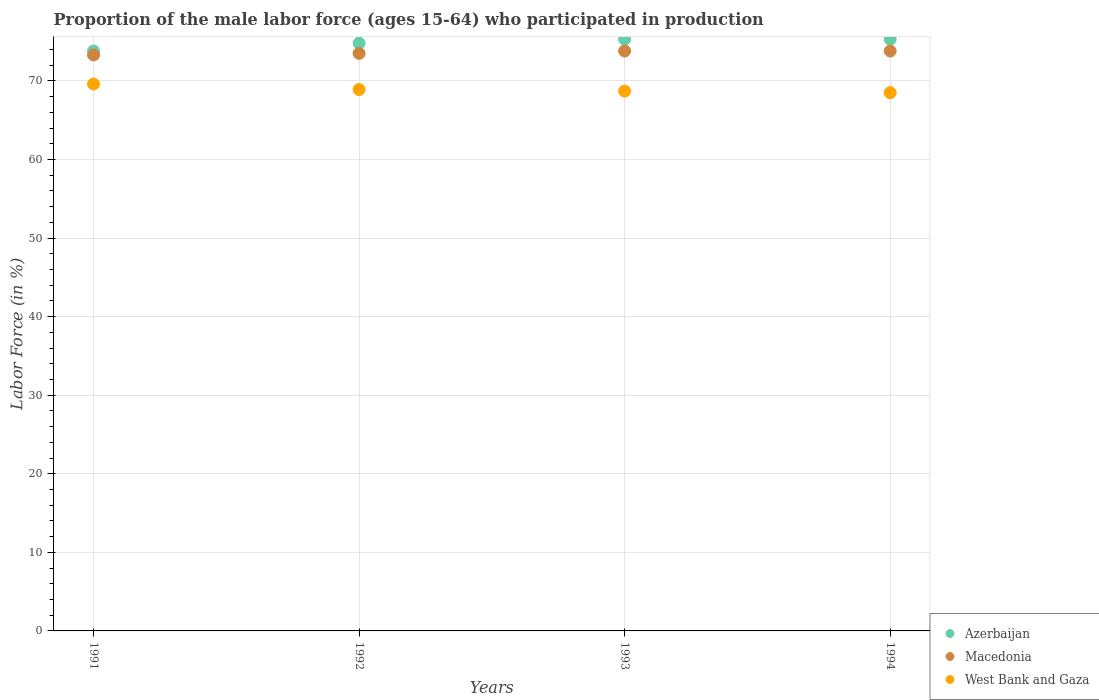Is the number of dotlines equal to the number of legend labels?
Offer a very short reply. Yes. What is the proportion of the male labor force who participated in production in West Bank and Gaza in 1993?
Provide a succinct answer. 68.7. Across all years, what is the maximum proportion of the male labor force who participated in production in Azerbaijan?
Provide a succinct answer. 75.3. Across all years, what is the minimum proportion of the male labor force who participated in production in West Bank and Gaza?
Give a very brief answer. 68.5. In which year was the proportion of the male labor force who participated in production in West Bank and Gaza maximum?
Keep it short and to the point. 1991. What is the total proportion of the male labor force who participated in production in Macedonia in the graph?
Give a very brief answer. 294.4. What is the difference between the proportion of the male labor force who participated in production in Azerbaijan in 1993 and the proportion of the male labor force who participated in production in Macedonia in 1994?
Give a very brief answer. 1.5. What is the average proportion of the male labor force who participated in production in West Bank and Gaza per year?
Make the answer very short. 68.92. In the year 1993, what is the difference between the proportion of the male labor force who participated in production in Macedonia and proportion of the male labor force who participated in production in West Bank and Gaza?
Ensure brevity in your answer.  5.1. In how many years, is the proportion of the male labor force who participated in production in Macedonia greater than 50 %?
Provide a short and direct response. 4. What is the ratio of the proportion of the male labor force who participated in production in Azerbaijan in 1991 to that in 1993?
Ensure brevity in your answer.  0.98. Is the proportion of the male labor force who participated in production in Macedonia in 1992 less than that in 1993?
Make the answer very short. Yes. What is the difference between the highest and the second highest proportion of the male labor force who participated in production in West Bank and Gaza?
Your response must be concise. 0.7. What is the difference between the highest and the lowest proportion of the male labor force who participated in production in West Bank and Gaza?
Make the answer very short. 1.1. In how many years, is the proportion of the male labor force who participated in production in Macedonia greater than the average proportion of the male labor force who participated in production in Macedonia taken over all years?
Give a very brief answer. 2. Is it the case that in every year, the sum of the proportion of the male labor force who participated in production in Macedonia and proportion of the male labor force who participated in production in Azerbaijan  is greater than the proportion of the male labor force who participated in production in West Bank and Gaza?
Ensure brevity in your answer.  Yes. Is the proportion of the male labor force who participated in production in West Bank and Gaza strictly greater than the proportion of the male labor force who participated in production in Azerbaijan over the years?
Provide a succinct answer. No. How many dotlines are there?
Provide a short and direct response. 3. How many years are there in the graph?
Make the answer very short. 4. What is the difference between two consecutive major ticks on the Y-axis?
Make the answer very short. 10. Where does the legend appear in the graph?
Offer a very short reply. Bottom right. What is the title of the graph?
Keep it short and to the point. Proportion of the male labor force (ages 15-64) who participated in production. What is the label or title of the Y-axis?
Make the answer very short. Labor Force (in %). What is the Labor Force (in %) of Azerbaijan in 1991?
Your answer should be very brief. 73.8. What is the Labor Force (in %) in Macedonia in 1991?
Make the answer very short. 73.3. What is the Labor Force (in %) in West Bank and Gaza in 1991?
Keep it short and to the point. 69.6. What is the Labor Force (in %) in Azerbaijan in 1992?
Your answer should be compact. 74.8. What is the Labor Force (in %) of Macedonia in 1992?
Your response must be concise. 73.5. What is the Labor Force (in %) in West Bank and Gaza in 1992?
Your answer should be compact. 68.9. What is the Labor Force (in %) in Azerbaijan in 1993?
Ensure brevity in your answer.  75.3. What is the Labor Force (in %) of Macedonia in 1993?
Ensure brevity in your answer.  73.8. What is the Labor Force (in %) of West Bank and Gaza in 1993?
Keep it short and to the point. 68.7. What is the Labor Force (in %) of Azerbaijan in 1994?
Make the answer very short. 75.3. What is the Labor Force (in %) of Macedonia in 1994?
Give a very brief answer. 73.8. What is the Labor Force (in %) in West Bank and Gaza in 1994?
Provide a short and direct response. 68.5. Across all years, what is the maximum Labor Force (in %) in Azerbaijan?
Offer a terse response. 75.3. Across all years, what is the maximum Labor Force (in %) of Macedonia?
Keep it short and to the point. 73.8. Across all years, what is the maximum Labor Force (in %) of West Bank and Gaza?
Provide a short and direct response. 69.6. Across all years, what is the minimum Labor Force (in %) in Azerbaijan?
Offer a very short reply. 73.8. Across all years, what is the minimum Labor Force (in %) of Macedonia?
Ensure brevity in your answer.  73.3. Across all years, what is the minimum Labor Force (in %) of West Bank and Gaza?
Keep it short and to the point. 68.5. What is the total Labor Force (in %) in Azerbaijan in the graph?
Your response must be concise. 299.2. What is the total Labor Force (in %) of Macedonia in the graph?
Offer a terse response. 294.4. What is the total Labor Force (in %) in West Bank and Gaza in the graph?
Ensure brevity in your answer.  275.7. What is the difference between the Labor Force (in %) in Macedonia in 1991 and that in 1992?
Offer a very short reply. -0.2. What is the difference between the Labor Force (in %) of West Bank and Gaza in 1991 and that in 1992?
Your response must be concise. 0.7. What is the difference between the Labor Force (in %) in Azerbaijan in 1991 and that in 1993?
Ensure brevity in your answer.  -1.5. What is the difference between the Labor Force (in %) in Azerbaijan in 1991 and that in 1994?
Your answer should be compact. -1.5. What is the difference between the Labor Force (in %) of Macedonia in 1991 and that in 1994?
Your answer should be very brief. -0.5. What is the difference between the Labor Force (in %) in Azerbaijan in 1992 and that in 1993?
Make the answer very short. -0.5. What is the difference between the Labor Force (in %) in Macedonia in 1992 and that in 1993?
Your answer should be compact. -0.3. What is the difference between the Labor Force (in %) of West Bank and Gaza in 1992 and that in 1993?
Offer a very short reply. 0.2. What is the difference between the Labor Force (in %) in West Bank and Gaza in 1992 and that in 1994?
Your answer should be very brief. 0.4. What is the difference between the Labor Force (in %) in Macedonia in 1993 and that in 1994?
Provide a short and direct response. 0. What is the difference between the Labor Force (in %) of West Bank and Gaza in 1993 and that in 1994?
Make the answer very short. 0.2. What is the difference between the Labor Force (in %) in Azerbaijan in 1991 and the Labor Force (in %) in West Bank and Gaza in 1992?
Offer a very short reply. 4.9. What is the difference between the Labor Force (in %) of Azerbaijan in 1991 and the Labor Force (in %) of Macedonia in 1993?
Your answer should be very brief. 0. What is the difference between the Labor Force (in %) of Azerbaijan in 1991 and the Labor Force (in %) of West Bank and Gaza in 1993?
Offer a terse response. 5.1. What is the difference between the Labor Force (in %) in Macedonia in 1991 and the Labor Force (in %) in West Bank and Gaza in 1993?
Offer a terse response. 4.6. What is the difference between the Labor Force (in %) of Azerbaijan in 1991 and the Labor Force (in %) of West Bank and Gaza in 1994?
Keep it short and to the point. 5.3. What is the difference between the Labor Force (in %) of Azerbaijan in 1992 and the Labor Force (in %) of Macedonia in 1993?
Your response must be concise. 1. What is the difference between the Labor Force (in %) in Macedonia in 1992 and the Labor Force (in %) in West Bank and Gaza in 1993?
Your response must be concise. 4.8. What is the difference between the Labor Force (in %) in Azerbaijan in 1992 and the Labor Force (in %) in West Bank and Gaza in 1994?
Make the answer very short. 6.3. What is the difference between the Labor Force (in %) of Macedonia in 1992 and the Labor Force (in %) of West Bank and Gaza in 1994?
Your response must be concise. 5. What is the difference between the Labor Force (in %) in Azerbaijan in 1993 and the Labor Force (in %) in Macedonia in 1994?
Provide a succinct answer. 1.5. What is the difference between the Labor Force (in %) in Azerbaijan in 1993 and the Labor Force (in %) in West Bank and Gaza in 1994?
Provide a succinct answer. 6.8. What is the average Labor Force (in %) of Azerbaijan per year?
Offer a terse response. 74.8. What is the average Labor Force (in %) of Macedonia per year?
Provide a short and direct response. 73.6. What is the average Labor Force (in %) of West Bank and Gaza per year?
Make the answer very short. 68.92. In the year 1991, what is the difference between the Labor Force (in %) in Azerbaijan and Labor Force (in %) in Macedonia?
Offer a terse response. 0.5. In the year 1991, what is the difference between the Labor Force (in %) of Macedonia and Labor Force (in %) of West Bank and Gaza?
Ensure brevity in your answer.  3.7. In the year 1992, what is the difference between the Labor Force (in %) in Azerbaijan and Labor Force (in %) in Macedonia?
Keep it short and to the point. 1.3. In the year 1992, what is the difference between the Labor Force (in %) in Macedonia and Labor Force (in %) in West Bank and Gaza?
Your answer should be compact. 4.6. In the year 1994, what is the difference between the Labor Force (in %) of Azerbaijan and Labor Force (in %) of Macedonia?
Offer a very short reply. 1.5. What is the ratio of the Labor Force (in %) of Azerbaijan in 1991 to that in 1992?
Ensure brevity in your answer.  0.99. What is the ratio of the Labor Force (in %) of Macedonia in 1991 to that in 1992?
Keep it short and to the point. 1. What is the ratio of the Labor Force (in %) in West Bank and Gaza in 1991 to that in 1992?
Ensure brevity in your answer.  1.01. What is the ratio of the Labor Force (in %) of Azerbaijan in 1991 to that in 1993?
Offer a terse response. 0.98. What is the ratio of the Labor Force (in %) in Macedonia in 1991 to that in 1993?
Provide a short and direct response. 0.99. What is the ratio of the Labor Force (in %) in West Bank and Gaza in 1991 to that in 1993?
Offer a very short reply. 1.01. What is the ratio of the Labor Force (in %) of Azerbaijan in 1991 to that in 1994?
Offer a very short reply. 0.98. What is the ratio of the Labor Force (in %) of West Bank and Gaza in 1991 to that in 1994?
Provide a short and direct response. 1.02. What is the ratio of the Labor Force (in %) of Azerbaijan in 1992 to that in 1993?
Give a very brief answer. 0.99. What is the ratio of the Labor Force (in %) in Azerbaijan in 1992 to that in 1994?
Your answer should be compact. 0.99. What is the ratio of the Labor Force (in %) in Azerbaijan in 1993 to that in 1994?
Ensure brevity in your answer.  1. What is the ratio of the Labor Force (in %) in West Bank and Gaza in 1993 to that in 1994?
Ensure brevity in your answer.  1. What is the difference between the highest and the second highest Labor Force (in %) in Macedonia?
Your answer should be compact. 0. What is the difference between the highest and the second highest Labor Force (in %) in West Bank and Gaza?
Provide a short and direct response. 0.7. What is the difference between the highest and the lowest Labor Force (in %) in Macedonia?
Provide a succinct answer. 0.5. 